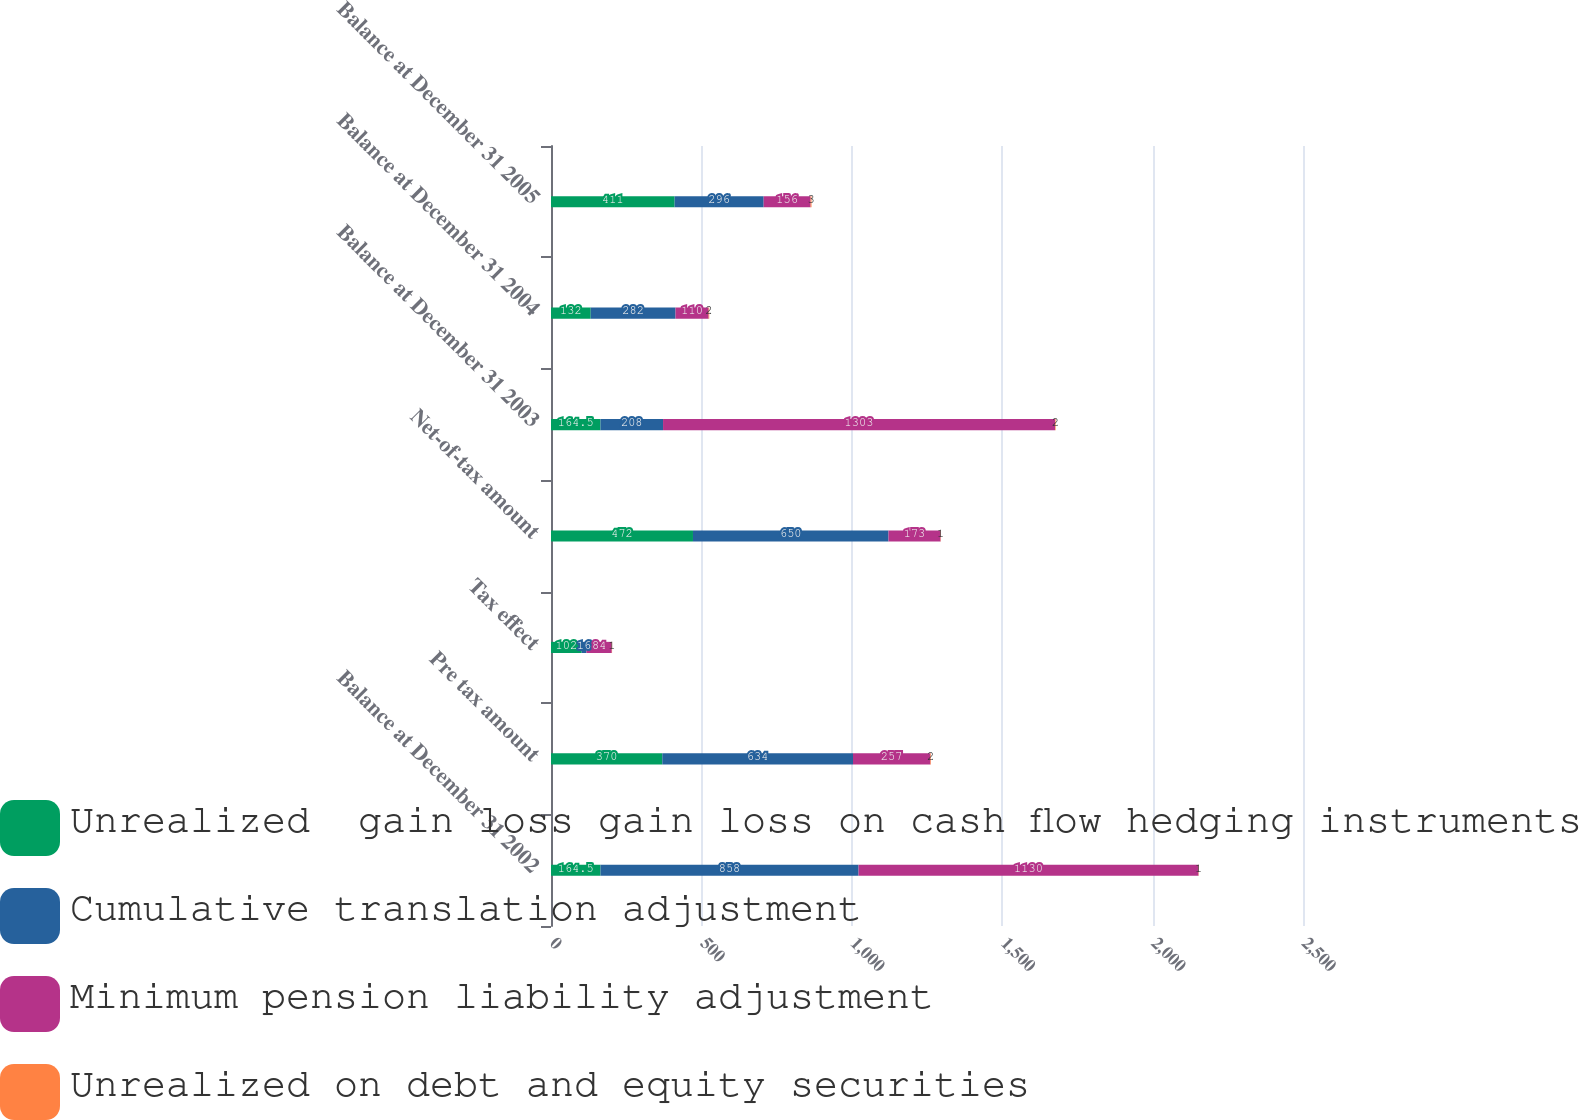Convert chart to OTSL. <chart><loc_0><loc_0><loc_500><loc_500><stacked_bar_chart><ecel><fcel>Balance at December 31 2002<fcel>Pre tax amount<fcel>Tax effect<fcel>Net-of-tax amount<fcel>Balance at December 31 2003<fcel>Balance at December 31 2004<fcel>Balance at December 31 2005<nl><fcel>Unrealized  gain loss gain loss on cash flow hedging instruments<fcel>164.5<fcel>370<fcel>102<fcel>472<fcel>164.5<fcel>132<fcel>411<nl><fcel>Cumulative translation adjustment<fcel>858<fcel>634<fcel>16<fcel>650<fcel>208<fcel>282<fcel>296<nl><fcel>Minimum pension liability adjustment<fcel>1130<fcel>257<fcel>84<fcel>173<fcel>1303<fcel>110<fcel>156<nl><fcel>Unrealized on debt and equity securities<fcel>1<fcel>2<fcel>1<fcel>1<fcel>2<fcel>2<fcel>3<nl></chart> 